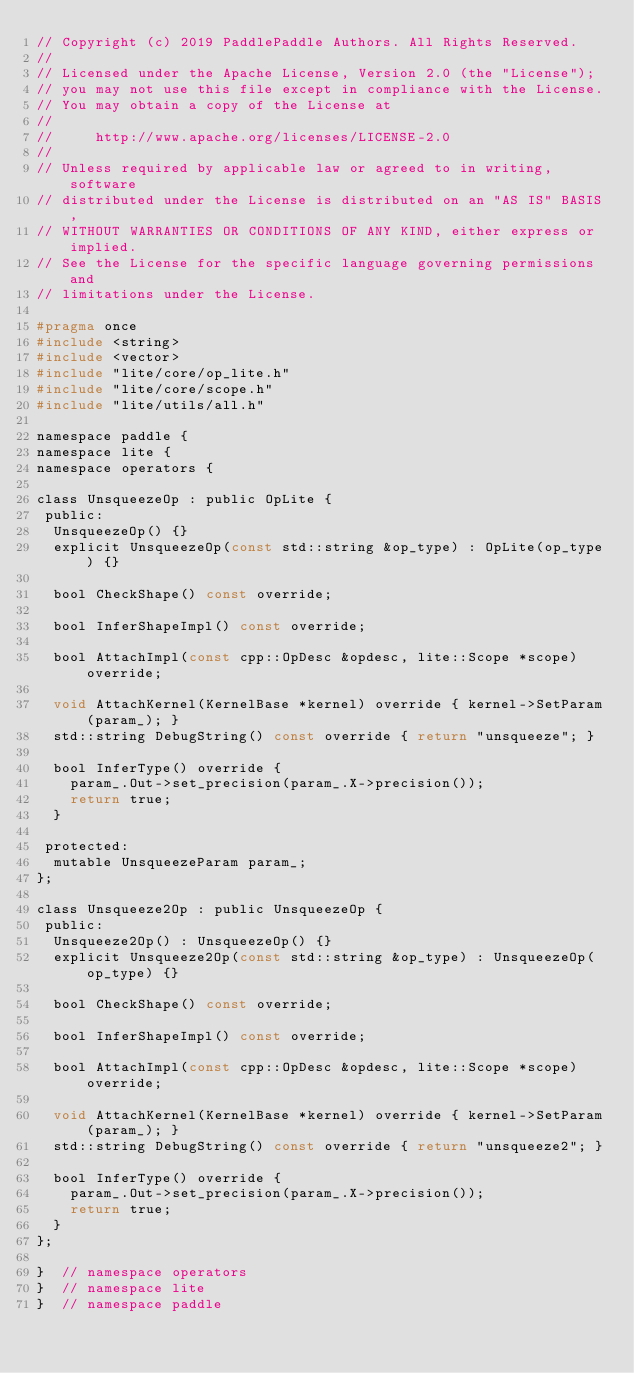Convert code to text. <code><loc_0><loc_0><loc_500><loc_500><_C_>// Copyright (c) 2019 PaddlePaddle Authors. All Rights Reserved.
//
// Licensed under the Apache License, Version 2.0 (the "License");
// you may not use this file except in compliance with the License.
// You may obtain a copy of the License at
//
//     http://www.apache.org/licenses/LICENSE-2.0
//
// Unless required by applicable law or agreed to in writing, software
// distributed under the License is distributed on an "AS IS" BASIS,
// WITHOUT WARRANTIES OR CONDITIONS OF ANY KIND, either express or implied.
// See the License for the specific language governing permissions and
// limitations under the License.

#pragma once
#include <string>
#include <vector>
#include "lite/core/op_lite.h"
#include "lite/core/scope.h"
#include "lite/utils/all.h"

namespace paddle {
namespace lite {
namespace operators {

class UnsqueezeOp : public OpLite {
 public:
  UnsqueezeOp() {}
  explicit UnsqueezeOp(const std::string &op_type) : OpLite(op_type) {}

  bool CheckShape() const override;

  bool InferShapeImpl() const override;

  bool AttachImpl(const cpp::OpDesc &opdesc, lite::Scope *scope) override;

  void AttachKernel(KernelBase *kernel) override { kernel->SetParam(param_); }
  std::string DebugString() const override { return "unsqueeze"; }

  bool InferType() override {
    param_.Out->set_precision(param_.X->precision());
    return true;
  }

 protected:
  mutable UnsqueezeParam param_;
};

class Unsqueeze2Op : public UnsqueezeOp {
 public:
  Unsqueeze2Op() : UnsqueezeOp() {}
  explicit Unsqueeze2Op(const std::string &op_type) : UnsqueezeOp(op_type) {}

  bool CheckShape() const override;

  bool InferShapeImpl() const override;

  bool AttachImpl(const cpp::OpDesc &opdesc, lite::Scope *scope) override;

  void AttachKernel(KernelBase *kernel) override { kernel->SetParam(param_); }
  std::string DebugString() const override { return "unsqueeze2"; }

  bool InferType() override {
    param_.Out->set_precision(param_.X->precision());
    return true;
  }
};

}  // namespace operators
}  // namespace lite
}  // namespace paddle
</code> 